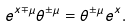<formula> <loc_0><loc_0><loc_500><loc_500>e ^ { x \mp \mu } \theta ^ { \pm \mu } = \theta ^ { \pm \mu } e ^ { x } .</formula> 